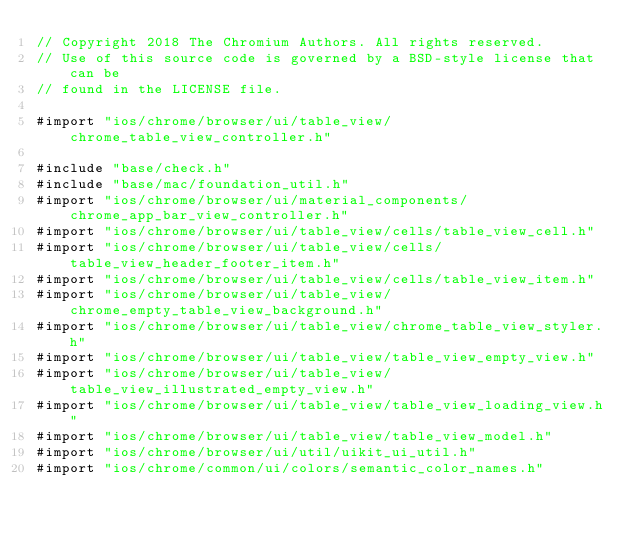Convert code to text. <code><loc_0><loc_0><loc_500><loc_500><_ObjectiveC_>// Copyright 2018 The Chromium Authors. All rights reserved.
// Use of this source code is governed by a BSD-style license that can be
// found in the LICENSE file.

#import "ios/chrome/browser/ui/table_view/chrome_table_view_controller.h"

#include "base/check.h"
#include "base/mac/foundation_util.h"
#import "ios/chrome/browser/ui/material_components/chrome_app_bar_view_controller.h"
#import "ios/chrome/browser/ui/table_view/cells/table_view_cell.h"
#import "ios/chrome/browser/ui/table_view/cells/table_view_header_footer_item.h"
#import "ios/chrome/browser/ui/table_view/cells/table_view_item.h"
#import "ios/chrome/browser/ui/table_view/chrome_empty_table_view_background.h"
#import "ios/chrome/browser/ui/table_view/chrome_table_view_styler.h"
#import "ios/chrome/browser/ui/table_view/table_view_empty_view.h"
#import "ios/chrome/browser/ui/table_view/table_view_illustrated_empty_view.h"
#import "ios/chrome/browser/ui/table_view/table_view_loading_view.h"
#import "ios/chrome/browser/ui/table_view/table_view_model.h"
#import "ios/chrome/browser/ui/util/uikit_ui_util.h"
#import "ios/chrome/common/ui/colors/semantic_color_names.h"
</code> 